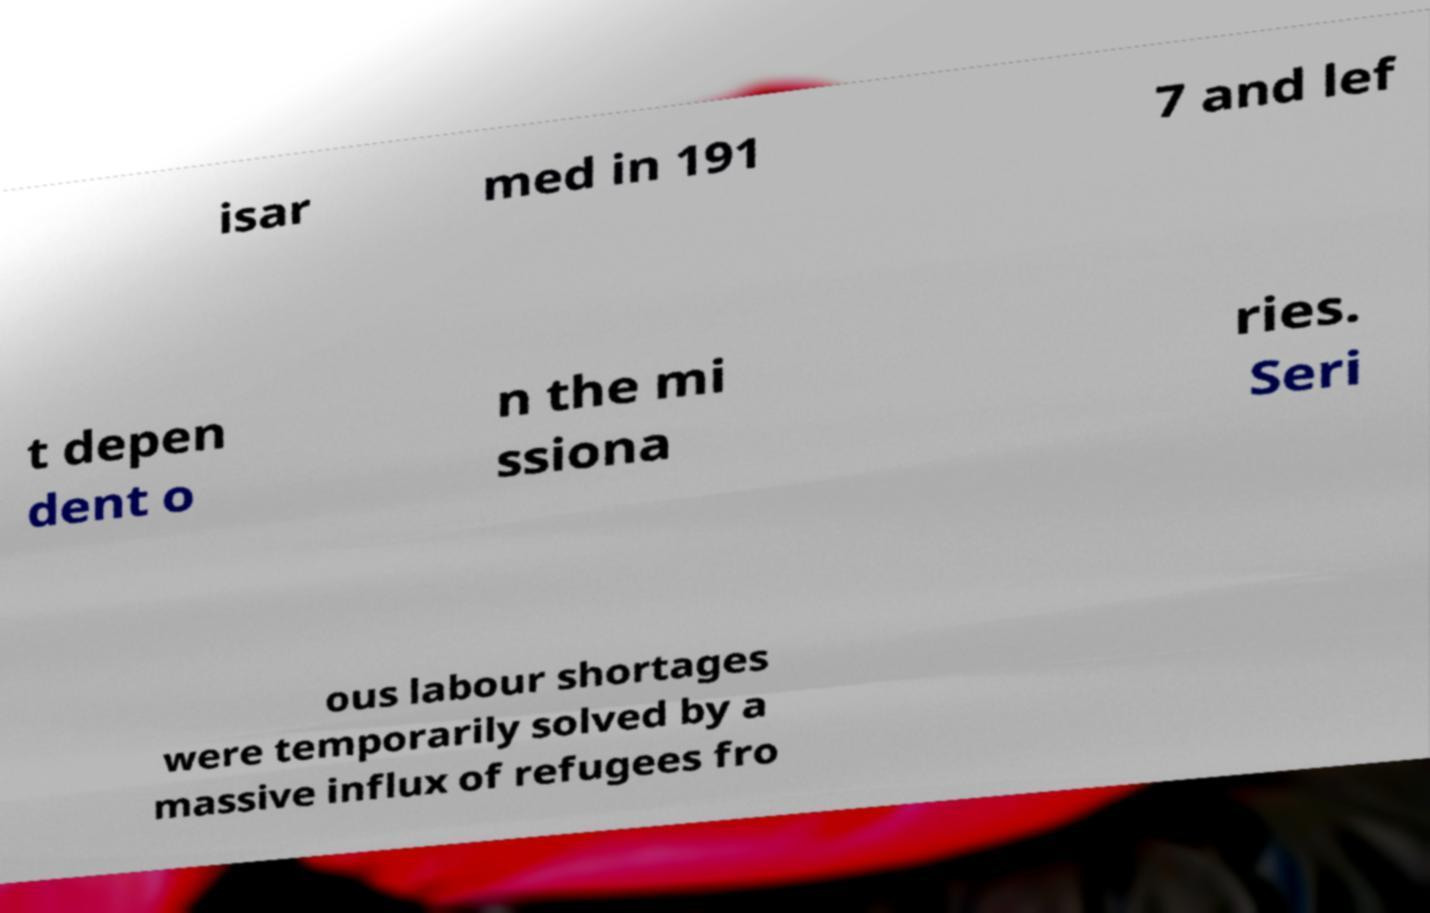What messages or text are displayed in this image? I need them in a readable, typed format. isar med in 191 7 and lef t depen dent o n the mi ssiona ries. Seri ous labour shortages were temporarily solved by a massive influx of refugees fro 